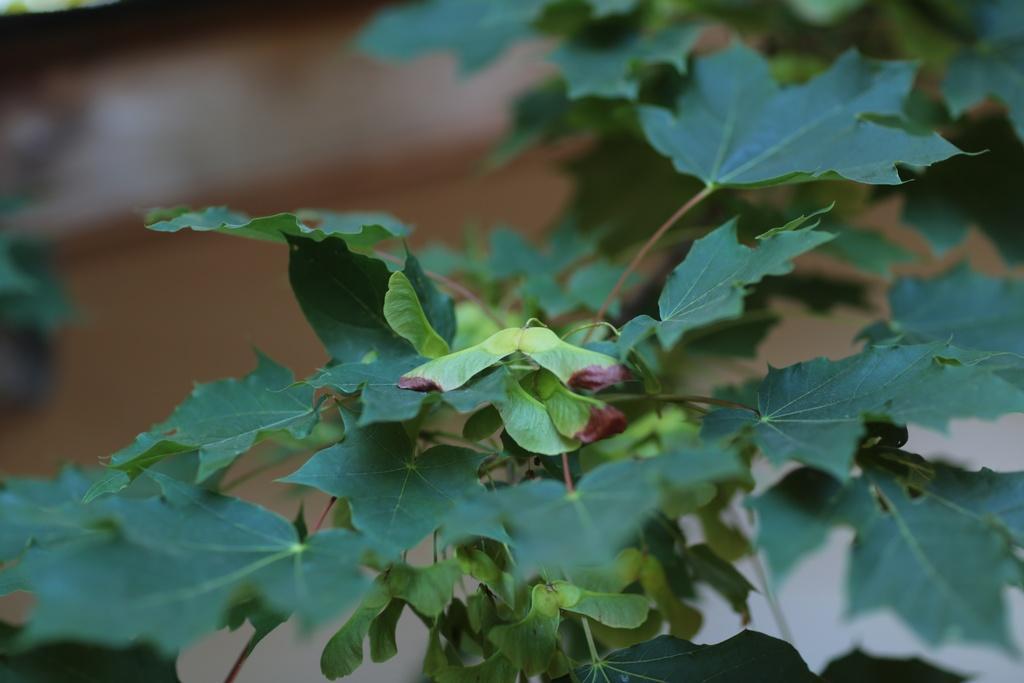In one or two sentences, can you explain what this image depicts? In this picture we can see a plant. On the left we can see leaves. On the top left there is a ground. 